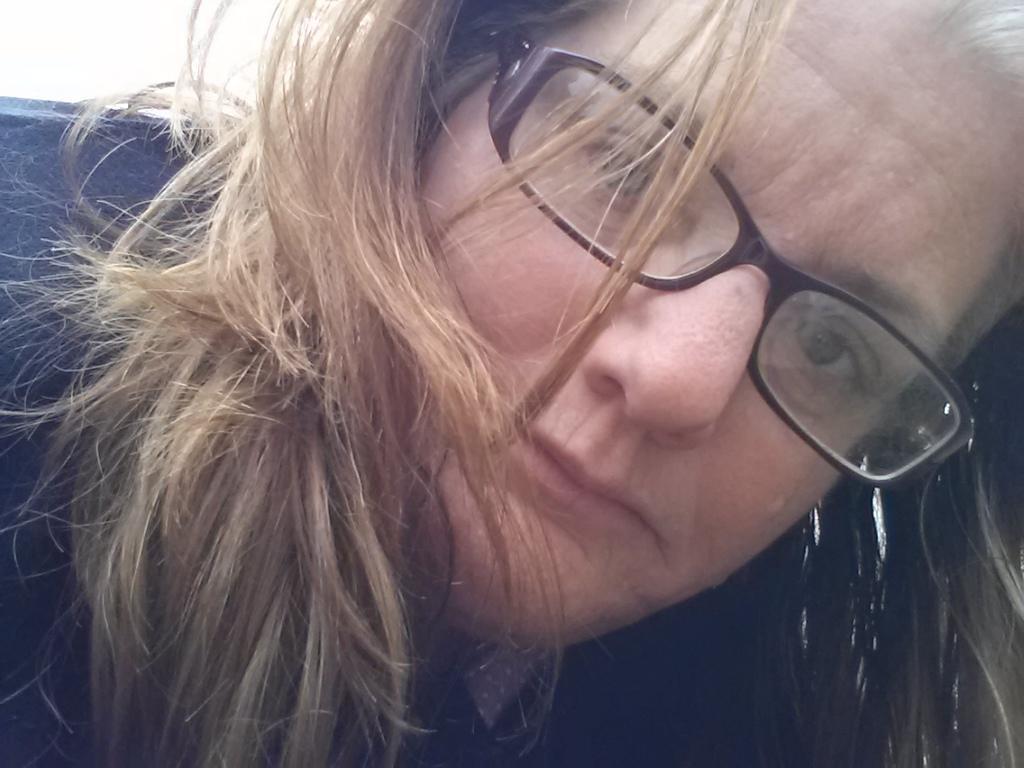Can you describe this image briefly? In this image I can see a person wearing spectacles. 